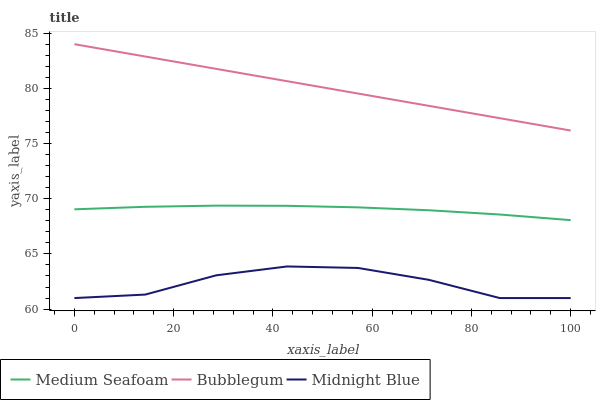Does Midnight Blue have the minimum area under the curve?
Answer yes or no. Yes. Does Bubblegum have the maximum area under the curve?
Answer yes or no. Yes. Does Bubblegum have the minimum area under the curve?
Answer yes or no. No. Does Midnight Blue have the maximum area under the curve?
Answer yes or no. No. Is Bubblegum the smoothest?
Answer yes or no. Yes. Is Midnight Blue the roughest?
Answer yes or no. Yes. Is Midnight Blue the smoothest?
Answer yes or no. No. Is Bubblegum the roughest?
Answer yes or no. No. Does Midnight Blue have the lowest value?
Answer yes or no. Yes. Does Bubblegum have the lowest value?
Answer yes or no. No. Does Bubblegum have the highest value?
Answer yes or no. Yes. Does Midnight Blue have the highest value?
Answer yes or no. No. Is Midnight Blue less than Medium Seafoam?
Answer yes or no. Yes. Is Bubblegum greater than Midnight Blue?
Answer yes or no. Yes. Does Midnight Blue intersect Medium Seafoam?
Answer yes or no. No. 